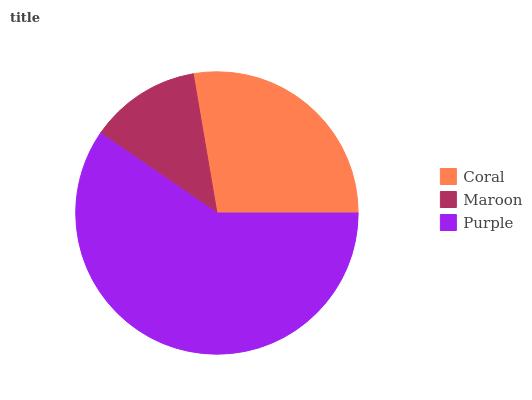Is Maroon the minimum?
Answer yes or no. Yes. Is Purple the maximum?
Answer yes or no. Yes. Is Purple the minimum?
Answer yes or no. No. Is Maroon the maximum?
Answer yes or no. No. Is Purple greater than Maroon?
Answer yes or no. Yes. Is Maroon less than Purple?
Answer yes or no. Yes. Is Maroon greater than Purple?
Answer yes or no. No. Is Purple less than Maroon?
Answer yes or no. No. Is Coral the high median?
Answer yes or no. Yes. Is Coral the low median?
Answer yes or no. Yes. Is Maroon the high median?
Answer yes or no. No. Is Purple the low median?
Answer yes or no. No. 